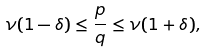Convert formula to latex. <formula><loc_0><loc_0><loc_500><loc_500>\nu ( 1 - \delta ) \leq \frac { p } { q } \leq \nu ( 1 + \delta ) ,</formula> 